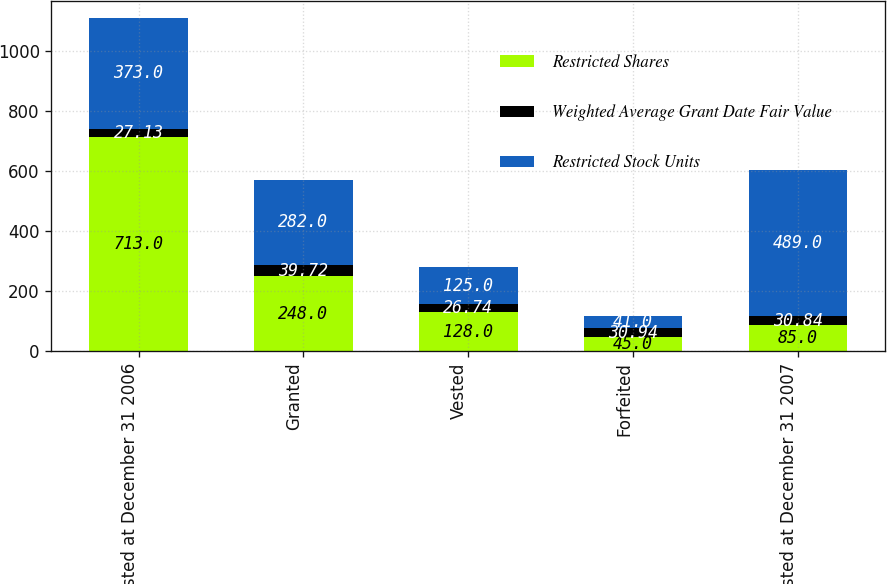Convert chart to OTSL. <chart><loc_0><loc_0><loc_500><loc_500><stacked_bar_chart><ecel><fcel>Unvested at December 31 2006<fcel>Granted<fcel>Vested<fcel>Forfeited<fcel>Unvested at December 31 2007<nl><fcel>Restricted Shares<fcel>713<fcel>248<fcel>128<fcel>45<fcel>85<nl><fcel>Weighted Average Grant Date Fair Value<fcel>27.13<fcel>39.72<fcel>26.74<fcel>30.94<fcel>30.84<nl><fcel>Restricted Stock Units<fcel>373<fcel>282<fcel>125<fcel>41<fcel>489<nl></chart> 